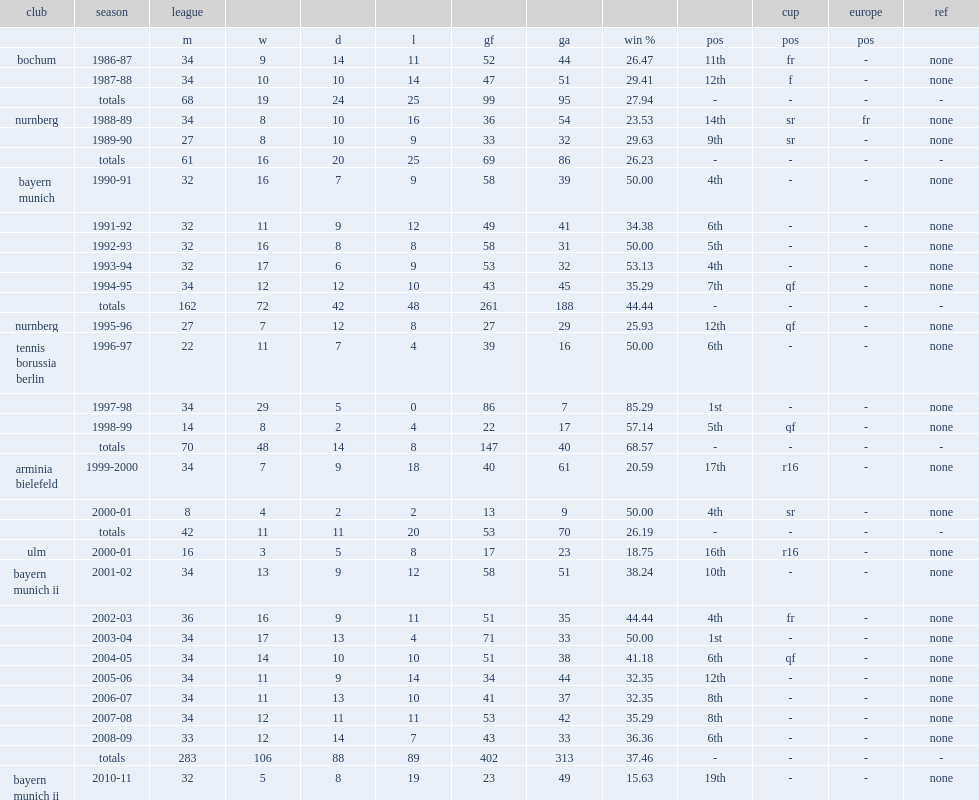Which club finished the 1999-2000 season in 17th place? Arminia bielefeld. 